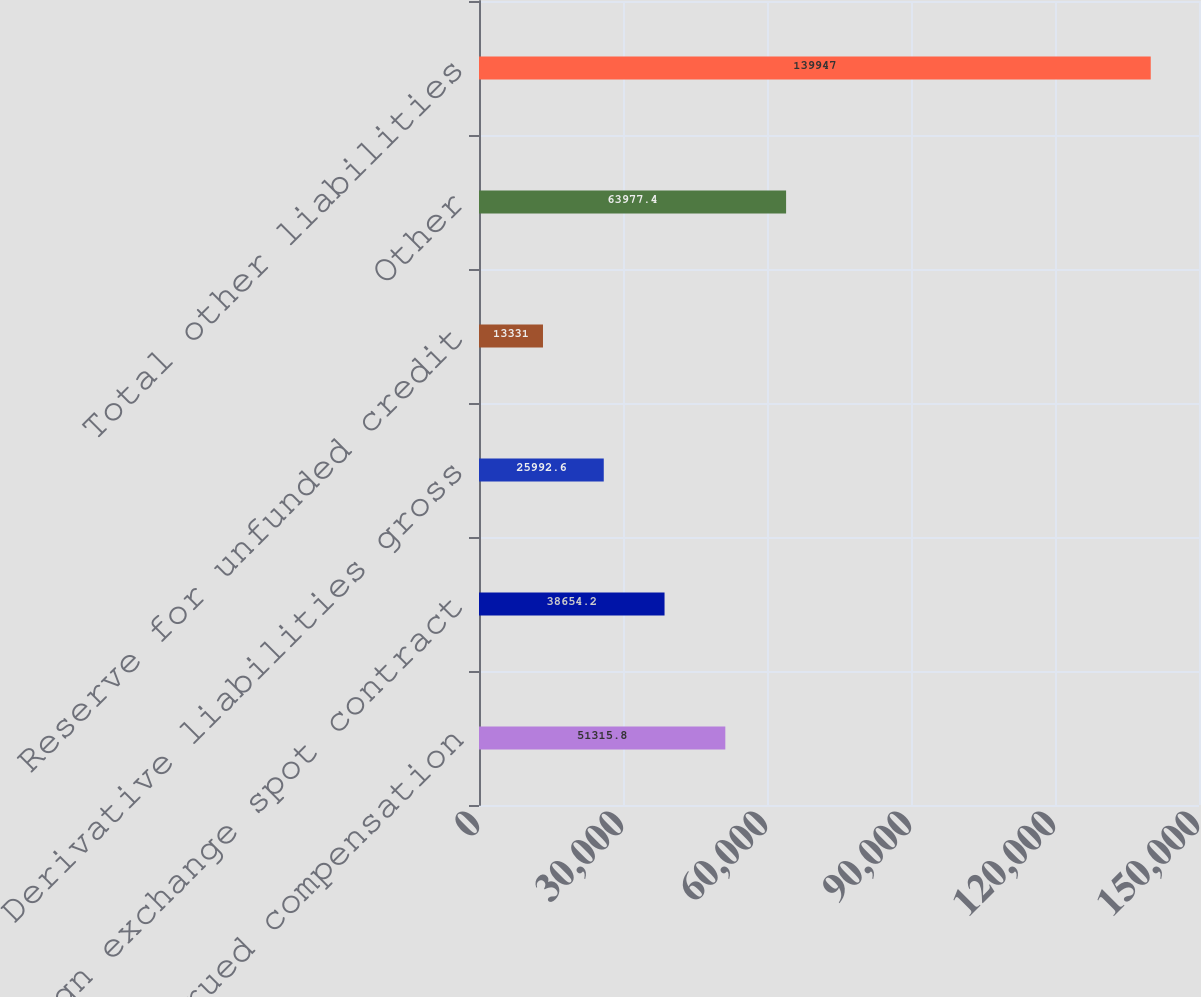Convert chart. <chart><loc_0><loc_0><loc_500><loc_500><bar_chart><fcel>Accrued compensation<fcel>Foreign exchange spot contract<fcel>Derivative liabilities gross<fcel>Reserve for unfunded credit<fcel>Other<fcel>Total other liabilities<nl><fcel>51315.8<fcel>38654.2<fcel>25992.6<fcel>13331<fcel>63977.4<fcel>139947<nl></chart> 